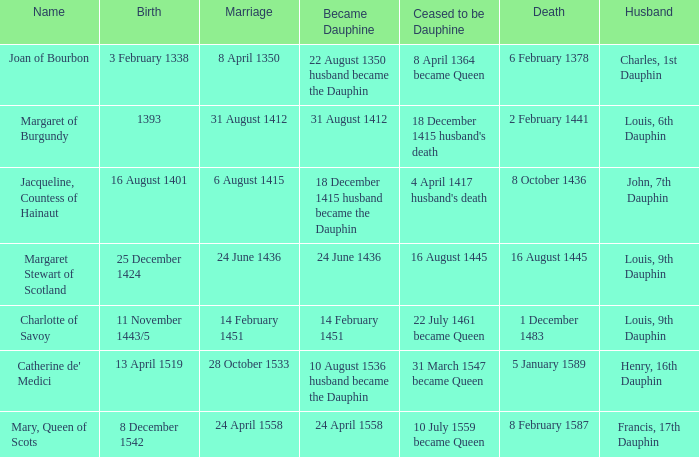Who is the husband when ceased to be dauphine is 22 july 1461 became queen? Louis, 9th Dauphin. Give me the full table as a dictionary. {'header': ['Name', 'Birth', 'Marriage', 'Became Dauphine', 'Ceased to be Dauphine', 'Death', 'Husband'], 'rows': [['Joan of Bourbon', '3 February 1338', '8 April 1350', '22 August 1350 husband became the Dauphin', '8 April 1364 became Queen', '6 February 1378', 'Charles, 1st Dauphin'], ['Margaret of Burgundy', '1393', '31 August 1412', '31 August 1412', "18 December 1415 husband's death", '2 February 1441', 'Louis, 6th Dauphin'], ['Jacqueline, Countess of Hainaut', '16 August 1401', '6 August 1415', '18 December 1415 husband became the Dauphin', "4 April 1417 husband's death", '8 October 1436', 'John, 7th Dauphin'], ['Margaret Stewart of Scotland', '25 December 1424', '24 June 1436', '24 June 1436', '16 August 1445', '16 August 1445', 'Louis, 9th Dauphin'], ['Charlotte of Savoy', '11 November 1443/5', '14 February 1451', '14 February 1451', '22 July 1461 became Queen', '1 December 1483', 'Louis, 9th Dauphin'], ["Catherine de' Medici", '13 April 1519', '28 October 1533', '10 August 1536 husband became the Dauphin', '31 March 1547 became Queen', '5 January 1589', 'Henry, 16th Dauphin'], ['Mary, Queen of Scots', '8 December 1542', '24 April 1558', '24 April 1558', '10 July 1559 became Queen', '8 February 1587', 'Francis, 17th Dauphin']]} 